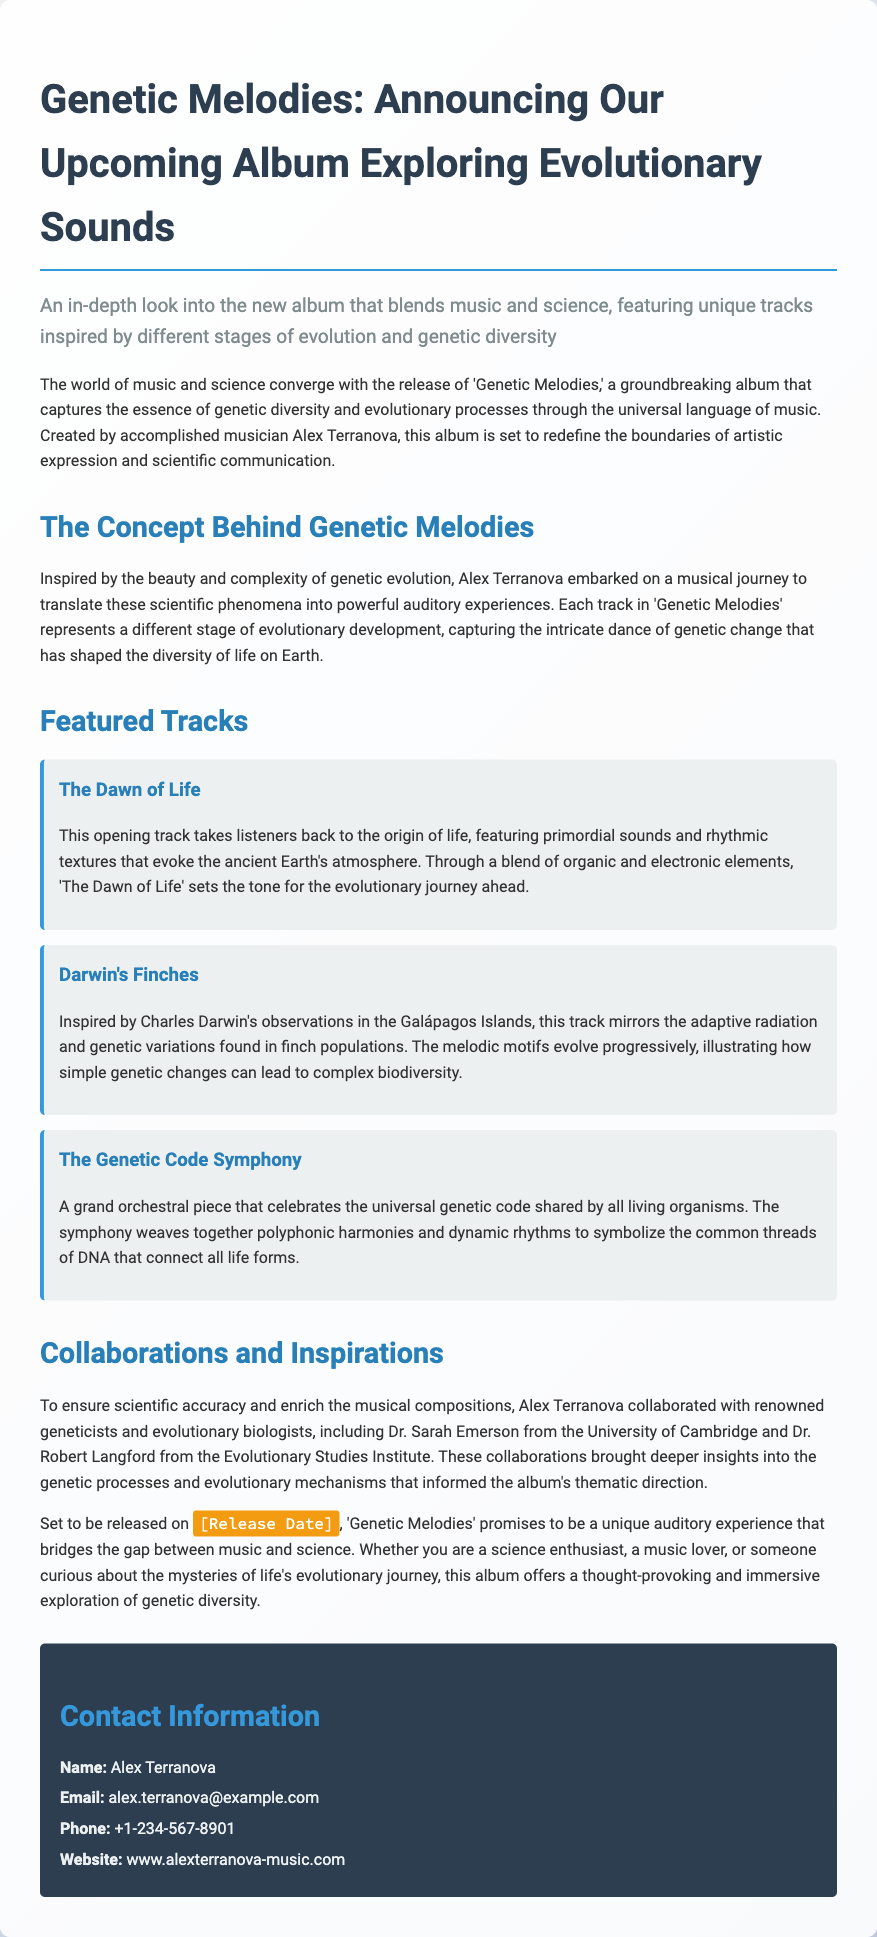What is the title of the album? The title is specifically mentioned at the beginning of the document as the focal point of the press release.
Answer: Genetic Melodies Who is the artist behind the album? The document introduces the main creator of the album in the opening paragraph, identifying their role.
Answer: Alex Terranova What is the release date? The release date is mentioned in a specific format within the text as a highlight but not provided explicitly.
Answer: [Release Date] Name one of the tracks featured in the album. The document lists several tracks under the "Featured Tracks" section, thus providing specific names.
Answer: The Dawn of Life Which institutions did Alex Terranova collaborate with? The document details collaborations with experts and their affiliations in the "Collaborations and Inspirations" section.
Answer: University of Cambridge, Evolutionary Studies Institute What genre does the album blend? The document emphasizes the connection between two areas by describing the nature of the album's creation.
Answer: Music and science What does the track "Darwin's Finches" represent? The explanation for the track indicates an evolutionary concept that the music embodies.
Answer: Adaptive radiation and genetic variations Who are the collaborators mentioned? The document lists the names of key figures involved in the making of the album, supporting claims of scientific accuracy.
Answer: Dr. Sarah Emerson, Dr. Robert Langford 